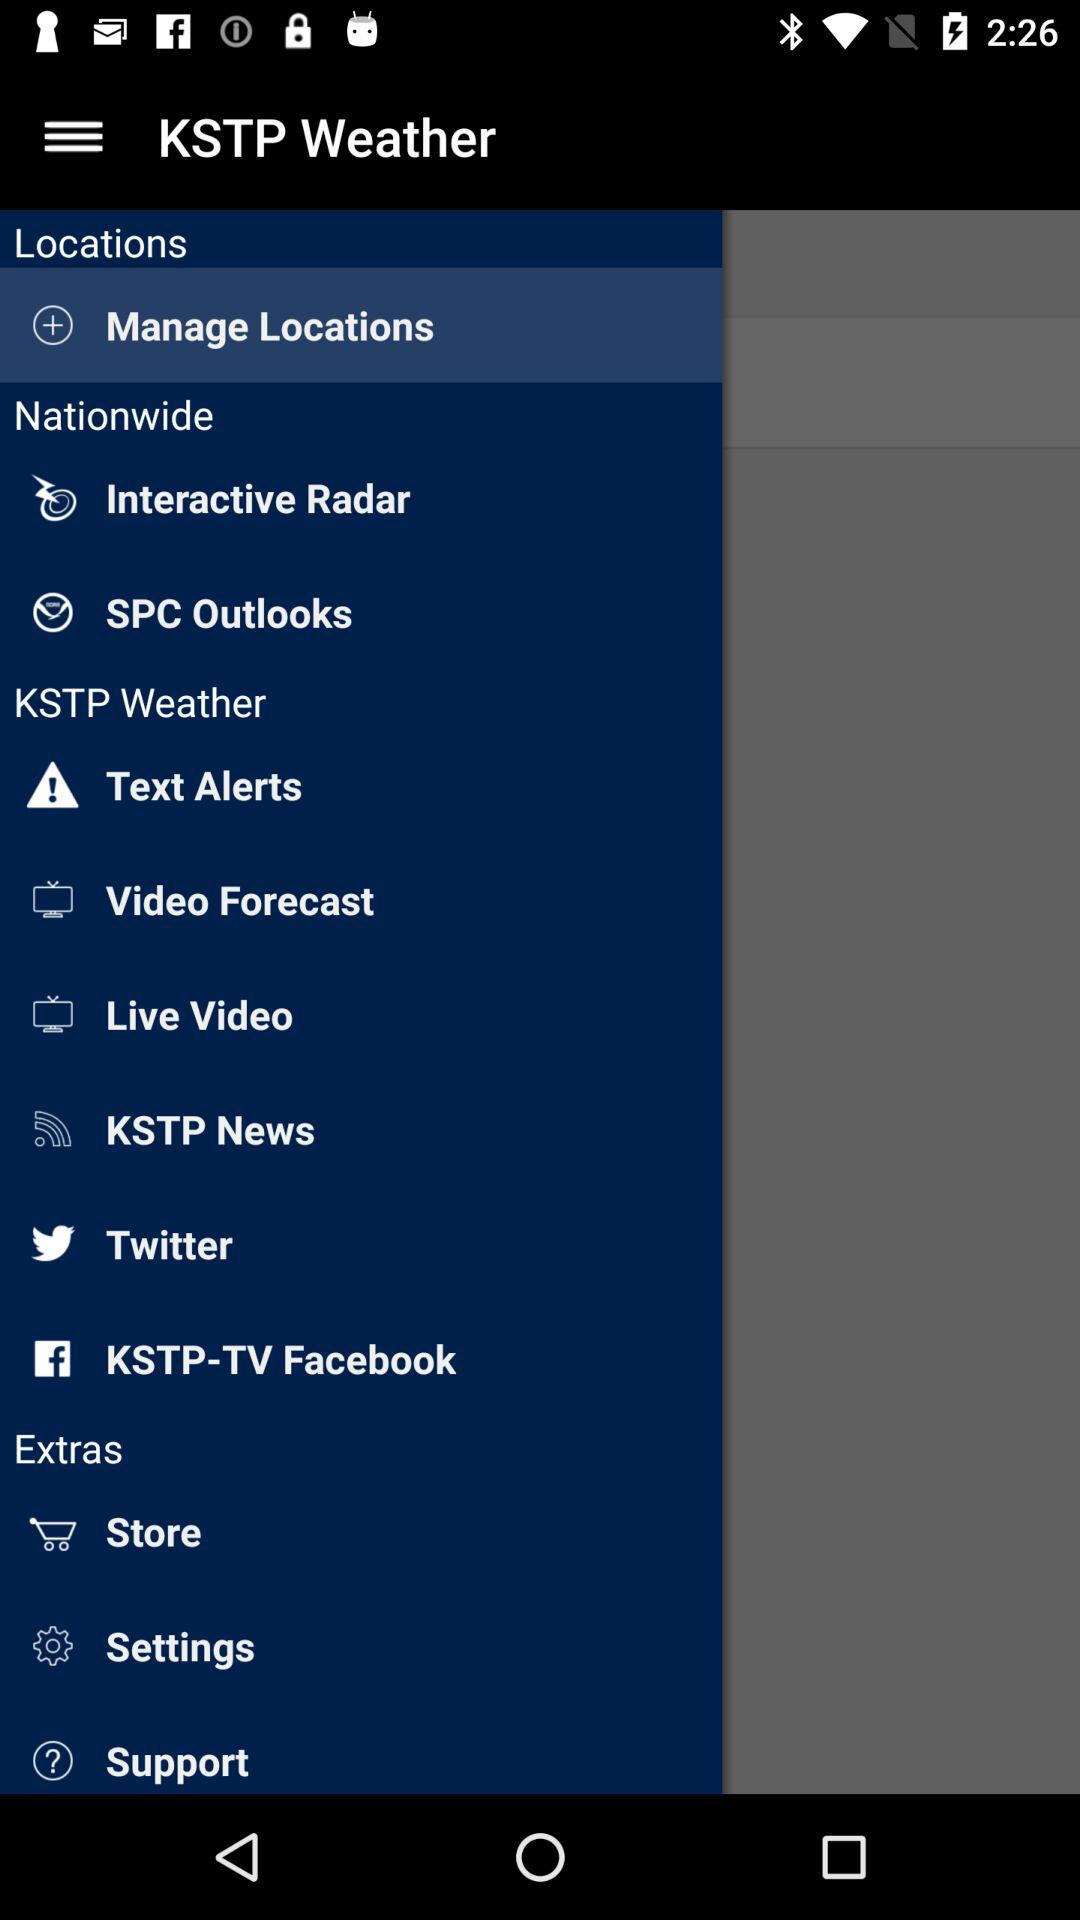What is the name of the application? The name of the application is "KSTP Weather". 